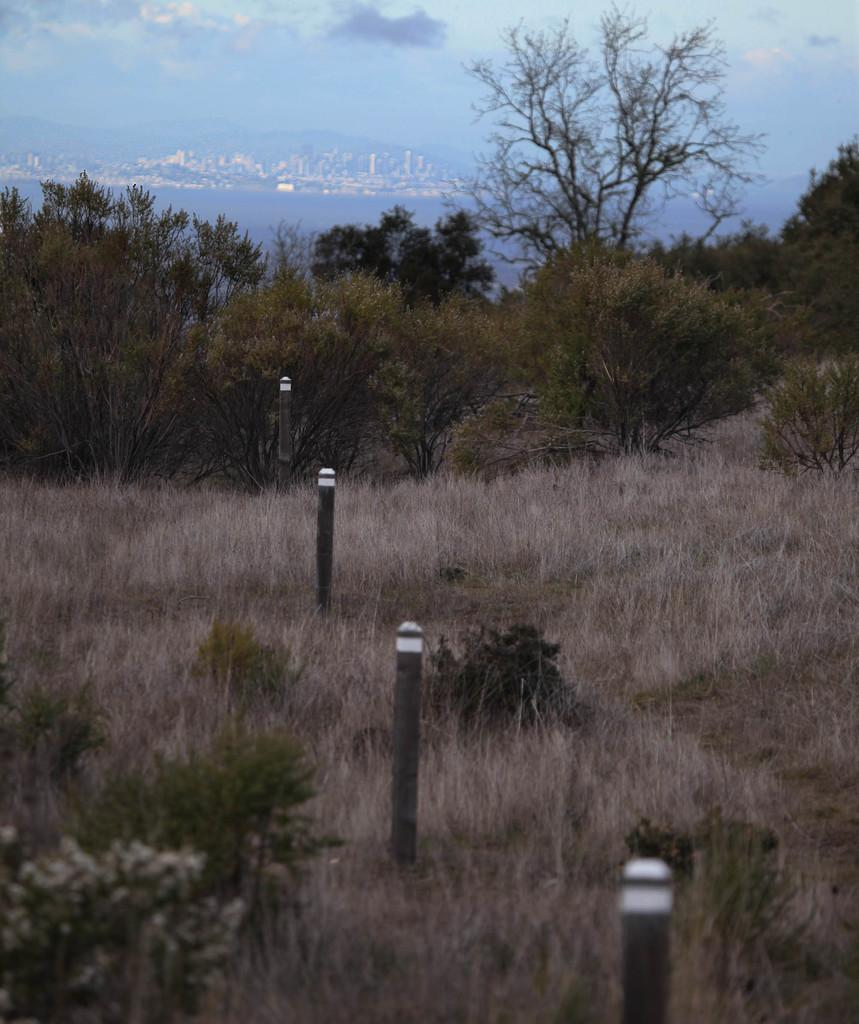What type of poles can be seen in the image? There are black and white colored poles in the image. What type of vegetation is visible in the image? There is grass visible in the image. What other natural elements can be seen in the image? There are trees in the image. What can be seen in the distance in the image? There is water, buildings, and the sky visible in the background of the image. Can you tell me how many yams are being carried by the man in the image? There is no man or yams present in the image. How does the water move in the image? The water does not move in the image; it is stationary in the background. 